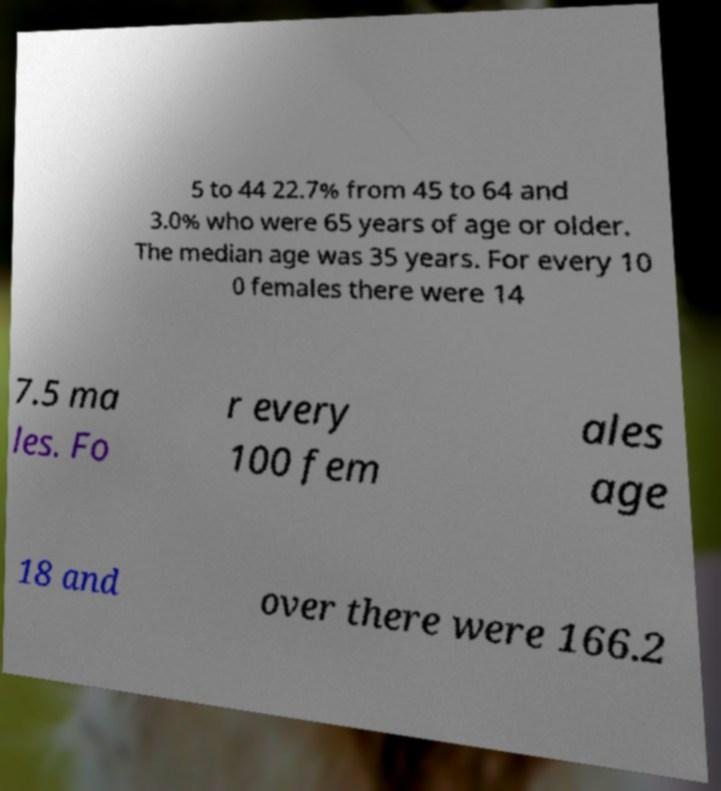Could you extract and type out the text from this image? 5 to 44 22.7% from 45 to 64 and 3.0% who were 65 years of age or older. The median age was 35 years. For every 10 0 females there were 14 7.5 ma les. Fo r every 100 fem ales age 18 and over there were 166.2 